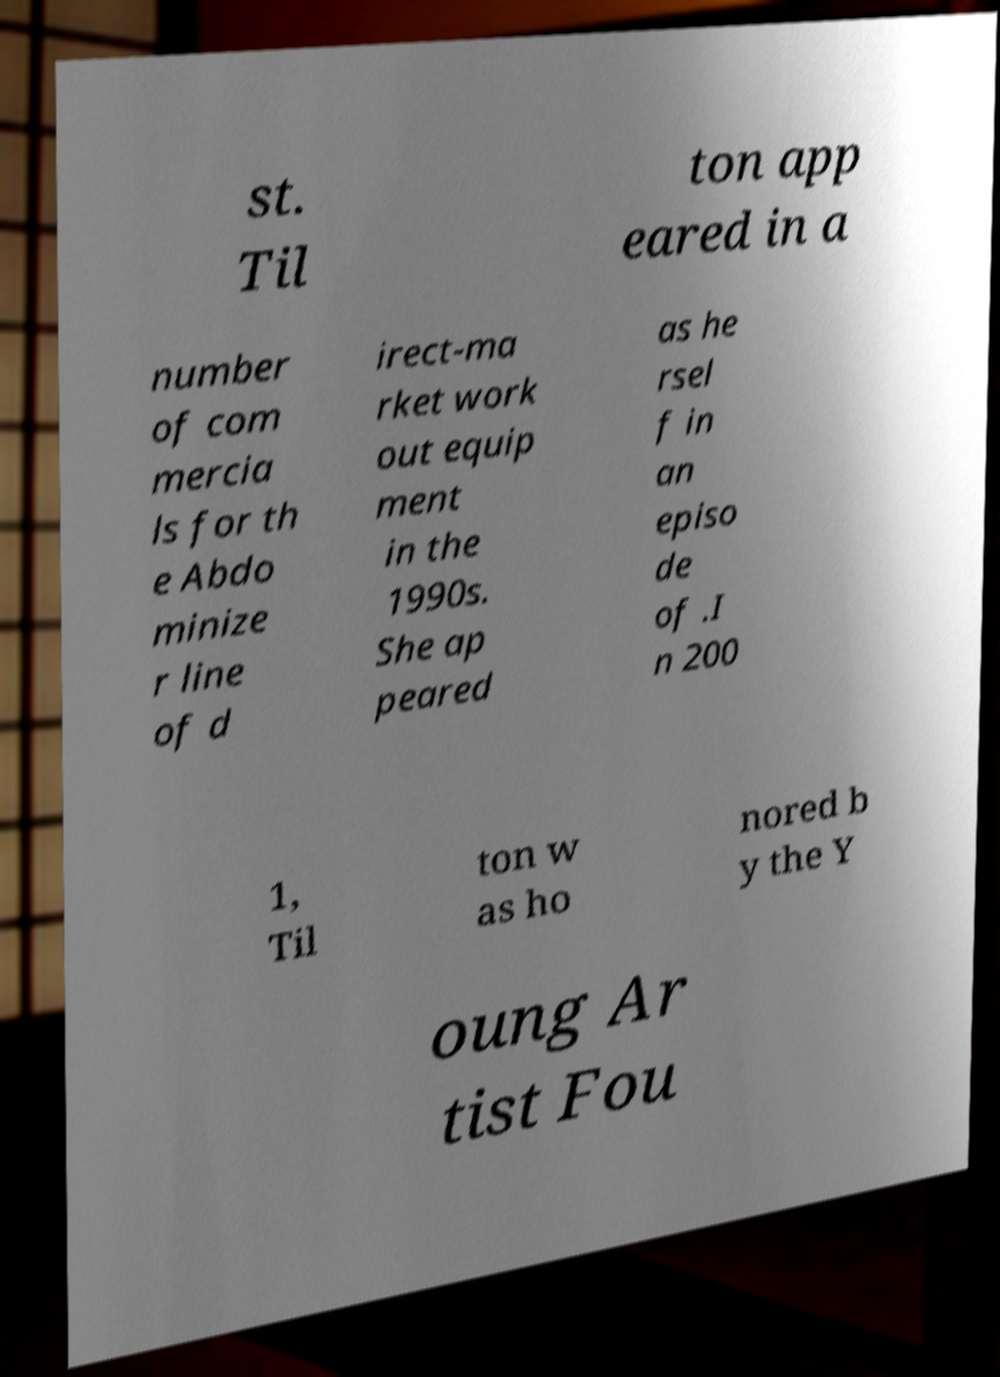Can you accurately transcribe the text from the provided image for me? st. Til ton app eared in a number of com mercia ls for th e Abdo minize r line of d irect-ma rket work out equip ment in the 1990s. She ap peared as he rsel f in an episo de of .I n 200 1, Til ton w as ho nored b y the Y oung Ar tist Fou 